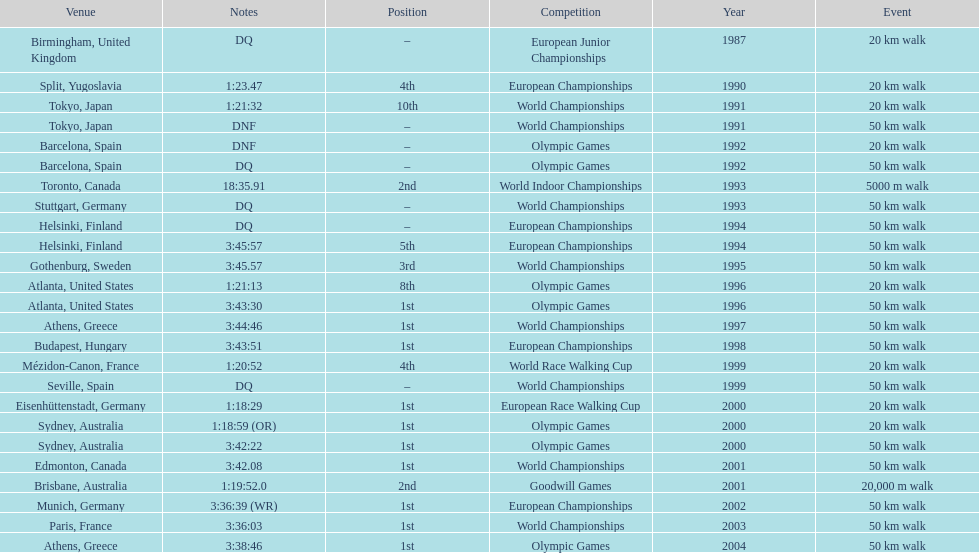What was the name of the competition that took place before the olympic games in 1996? World Championships. 